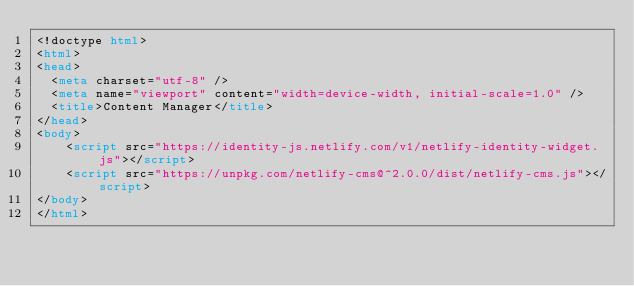<code> <loc_0><loc_0><loc_500><loc_500><_HTML_><!doctype html>
<html>
<head>
  <meta charset="utf-8" />
  <meta name="viewport" content="width=device-width, initial-scale=1.0" />
  <title>Content Manager</title>
</head>
<body>
    <script src="https://identity-js.netlify.com/v1/netlify-identity-widget.js"></script>
    <script src="https://unpkg.com/netlify-cms@^2.0.0/dist/netlify-cms.js"></script>
</body>
</html></code> 